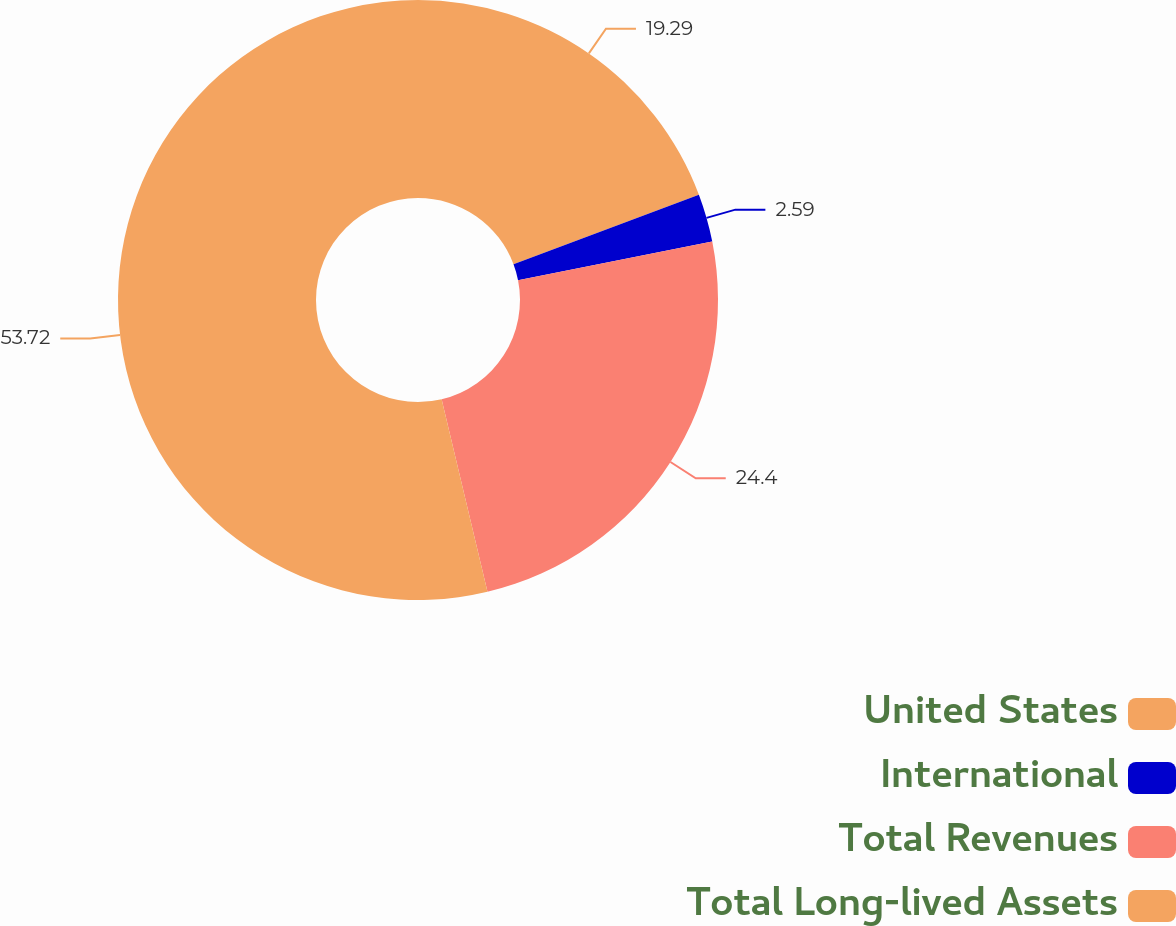<chart> <loc_0><loc_0><loc_500><loc_500><pie_chart><fcel>United States<fcel>International<fcel>Total Revenues<fcel>Total Long-lived Assets<nl><fcel>19.29%<fcel>2.59%<fcel>24.4%<fcel>53.72%<nl></chart> 